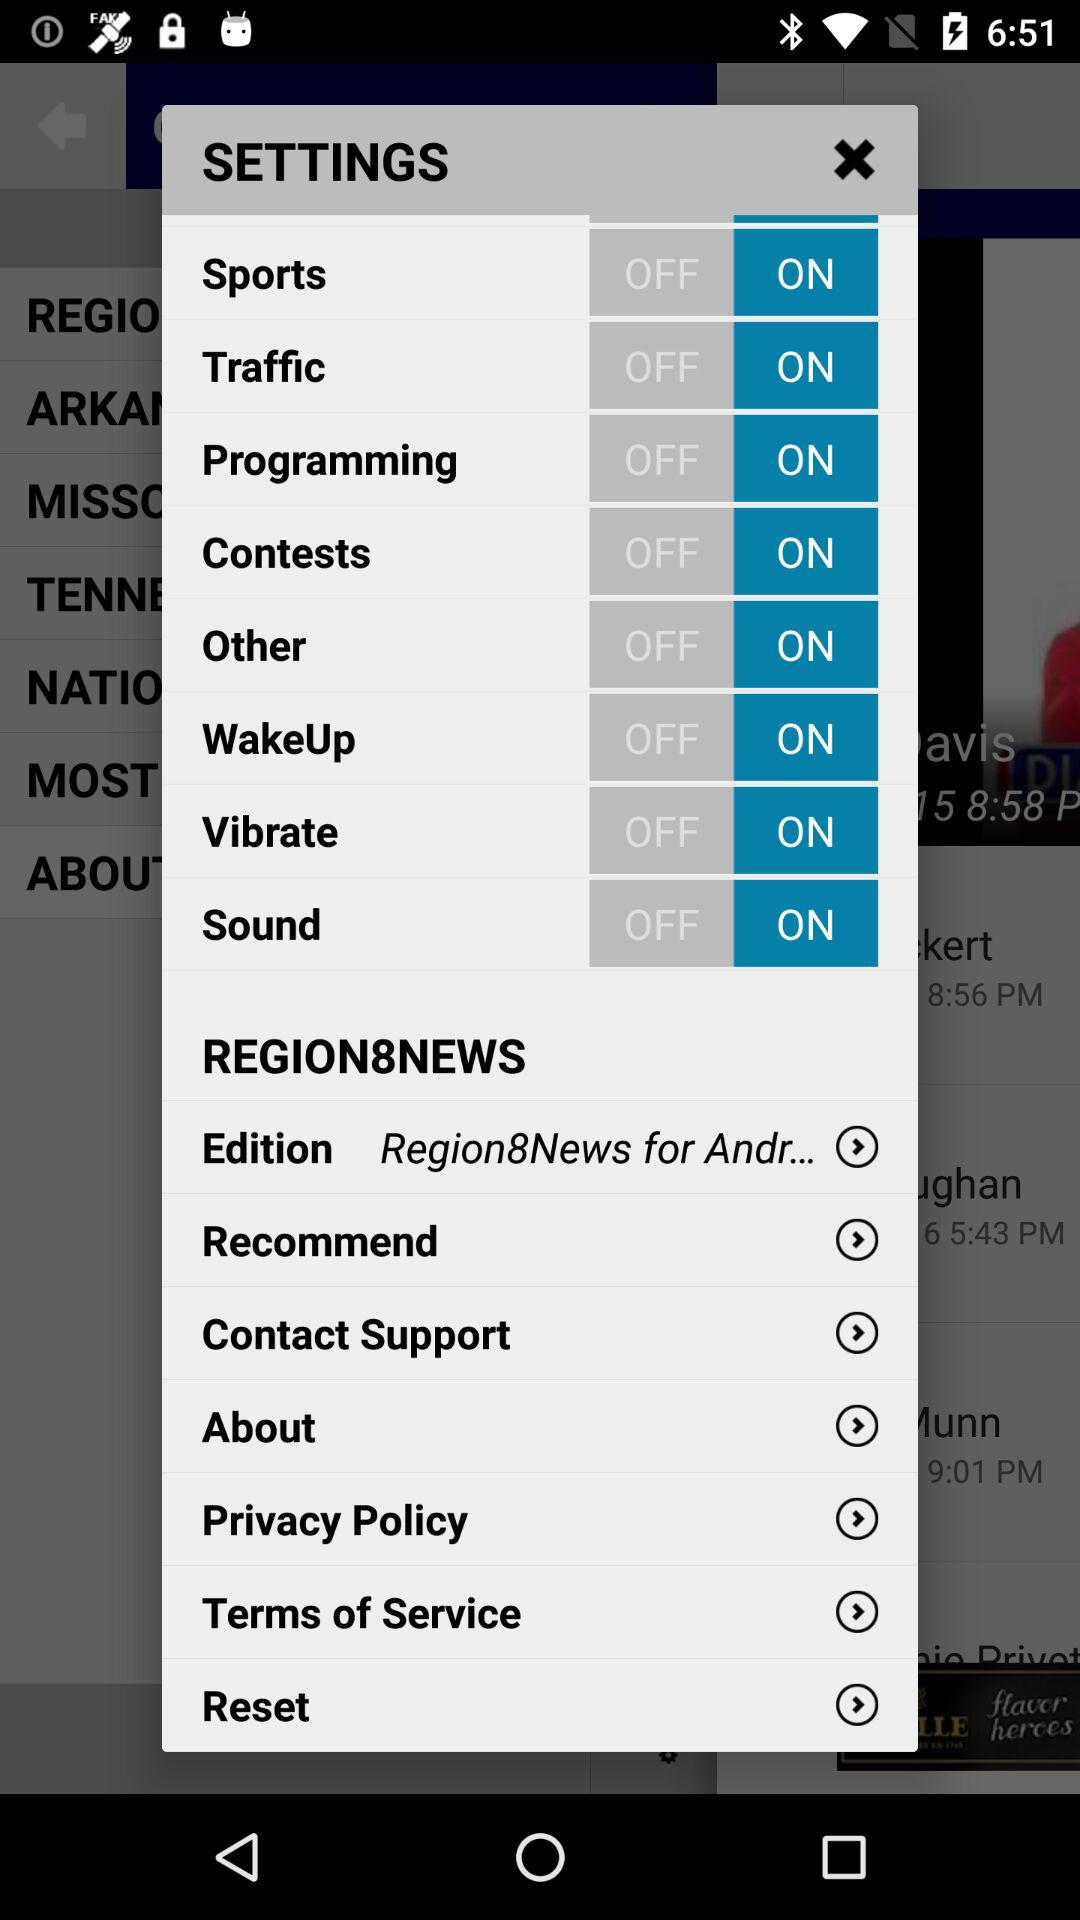What is the status of the "Other"? The status of the "Other" is "on". 